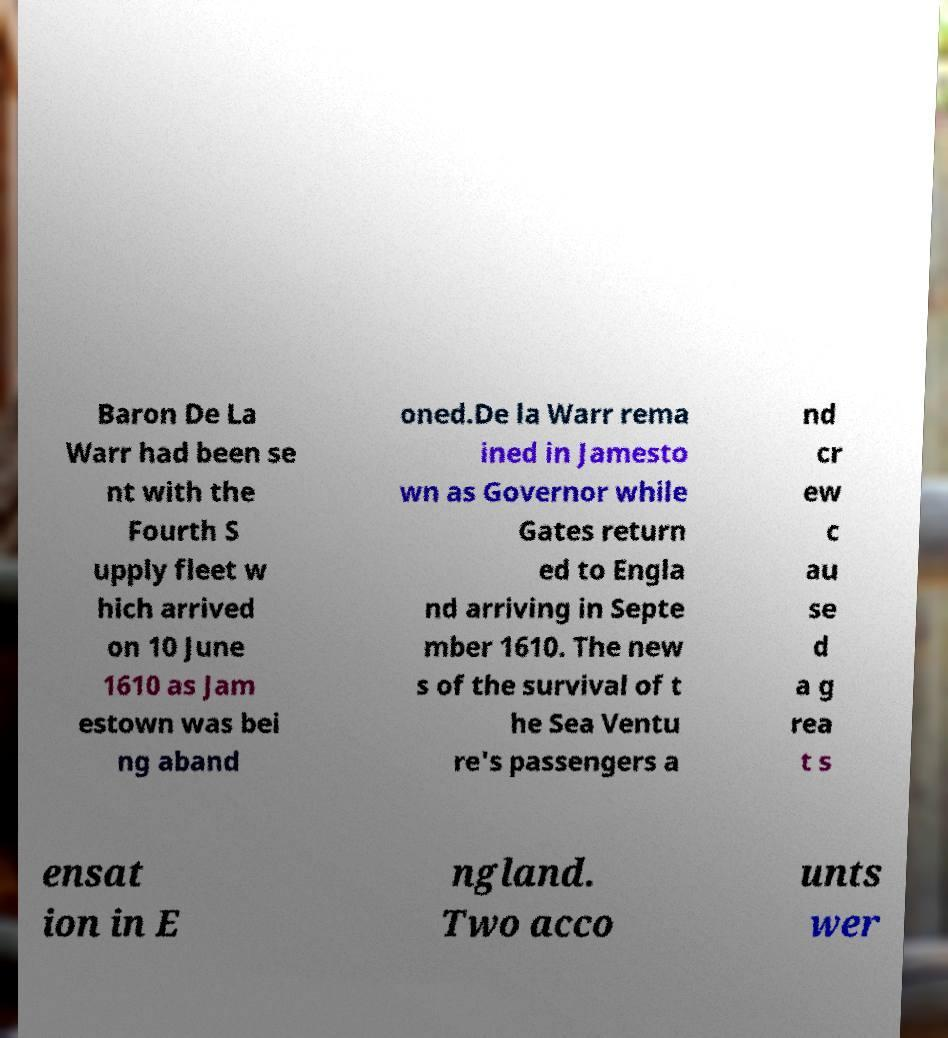Please read and relay the text visible in this image. What does it say? Baron De La Warr had been se nt with the Fourth S upply fleet w hich arrived on 10 June 1610 as Jam estown was bei ng aband oned.De la Warr rema ined in Jamesto wn as Governor while Gates return ed to Engla nd arriving in Septe mber 1610. The new s of the survival of t he Sea Ventu re's passengers a nd cr ew c au se d a g rea t s ensat ion in E ngland. Two acco unts wer 